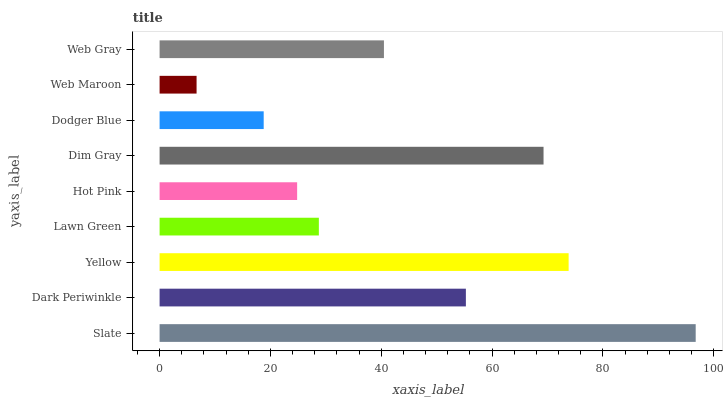Is Web Maroon the minimum?
Answer yes or no. Yes. Is Slate the maximum?
Answer yes or no. Yes. Is Dark Periwinkle the minimum?
Answer yes or no. No. Is Dark Periwinkle the maximum?
Answer yes or no. No. Is Slate greater than Dark Periwinkle?
Answer yes or no. Yes. Is Dark Periwinkle less than Slate?
Answer yes or no. Yes. Is Dark Periwinkle greater than Slate?
Answer yes or no. No. Is Slate less than Dark Periwinkle?
Answer yes or no. No. Is Web Gray the high median?
Answer yes or no. Yes. Is Web Gray the low median?
Answer yes or no. Yes. Is Lawn Green the high median?
Answer yes or no. No. Is Dodger Blue the low median?
Answer yes or no. No. 